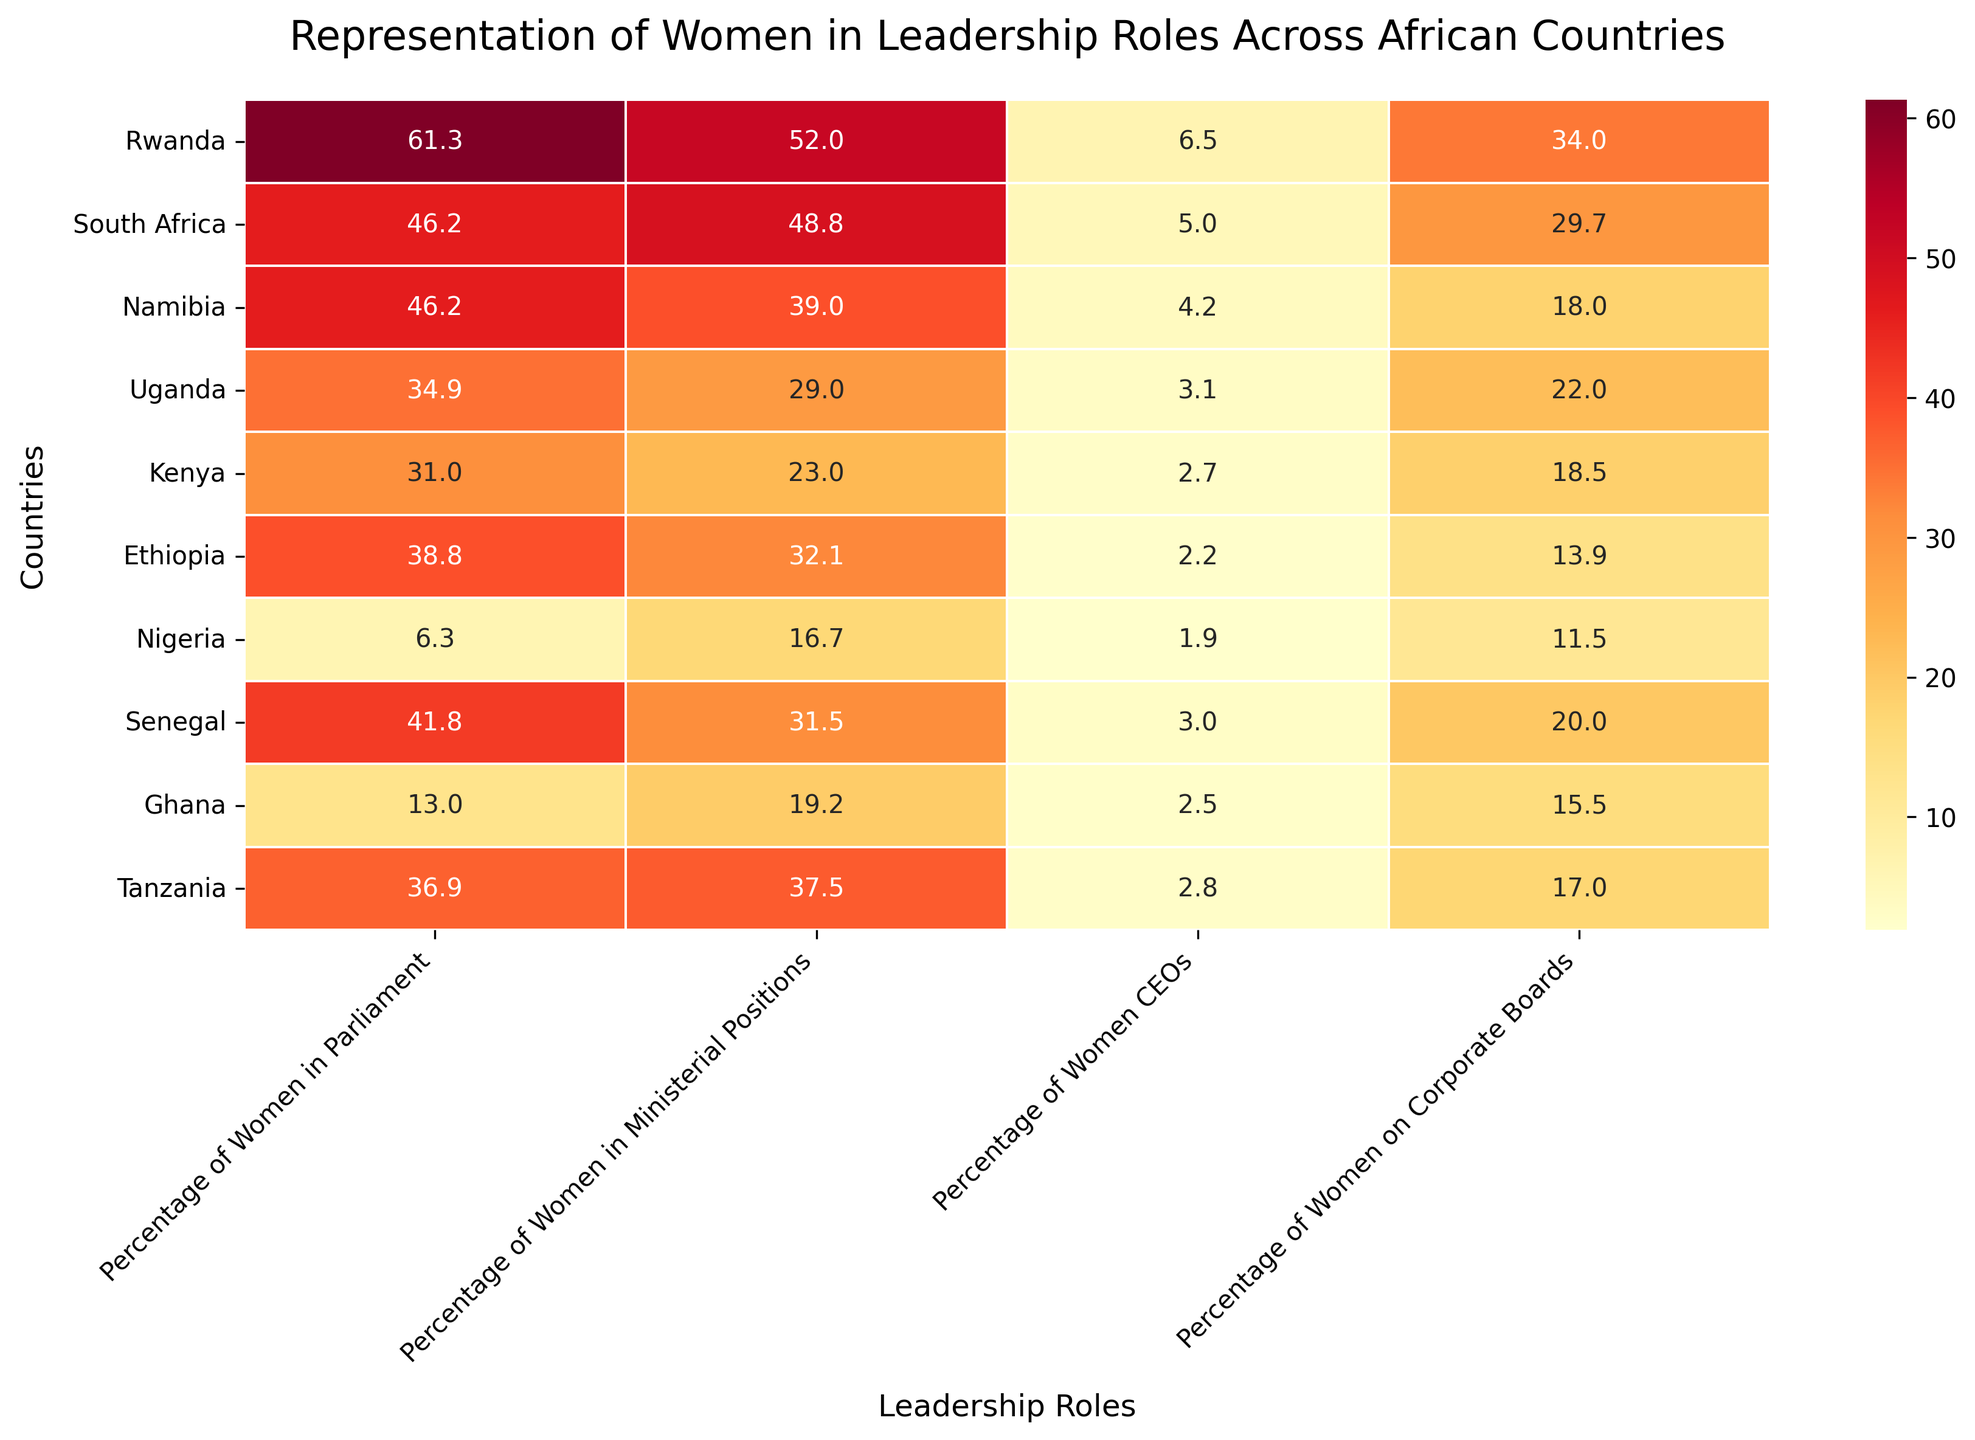What's the title of the plot? The title is located at the top of the plot and provides an overall description of what the heatmap represents.
Answer: Representation of Women in Leadership Roles Across African Countries How many leadership roles are represented in the heatmap? By looking at the x-axis labels, we can count the different categories listed to identify the number of leadership roles.
Answer: 4 Which country has the highest percentage of women in parliament? To find this, look at the cells under the "Percentage of Women in Parliament" column and identify the highest value.
Answer: Rwanda What is the average percentage of women in ministerial positions across all listed countries? Calculate the sum of the percentages for "Percentage of Women in Ministerial Positions" and then divide by the number of countries. Specifically, (52.0 + 48.8 + 39.0 + 29.0 + 23.0 + 32.1 + 16.7 + 31.5 + 19.2 + 37.5) / 10 = 32.48
Answer: 32.48 Which two countries have the closest percentage of women on corporate boards? Compare the values in the "Percentage of Women on Corporate Boards" column to find the two values that are numerically closest to each other.
Answer: Kenya (18.5) and Namibia (18.0) Which leadership role has the least representation of women on average across all countries? Calculate the average representation for each leadership role by summing the respective percentages and dividing by the number of countries, then identify the role with the lowest average. The averages are Parliament: 35.64, Ministerial: 32.48, CEOs: 3.19, Corporate Boards: 20.91. Hence, CEOs have the least representation.
Answer: CEOs Which country has the least representation of women as CEOs, and what is the percentage? Identify the lowest percentage in the "Percentage of Women CEOs" column to find the respective country.
Answer: Nigeria, 1.9 How does the representation of women in judiciary compare across Rwanda and South Africa? Look at the values under the "Percentage of Women in Judiciary" column for both Rwanda and South Africa to compare them directly.
Answer: Rwanda (43.0) vs South Africa (37.5) What is the difference in the percentage of women on corporate boards between Ghana and Nigeria? Subtract the percentage of women on corporate boards in Nigeria (11.5) from that in Ghana (15.5).
Answer: 4.0 Which country has the most balanced representation across all four leadership roles? Find the country where the percentages in each role are most consistent or closest to each other. Examine the range (maximum minus minimum) for each country. Rwanda (17.3 range), South Africa (19.1 range), Namibia (34.8 range), Uganda (25.9 range), Kenya (28.3 range), Ethiopia (27.0 range), Nigeria (14.8 range), Senegal (21.8 range), Ghana (16.7 range), Tanzania (34.7 range). Nigeria has the smallest range of 14.8, indicating the most balanced representation.
Answer: Nigeria 